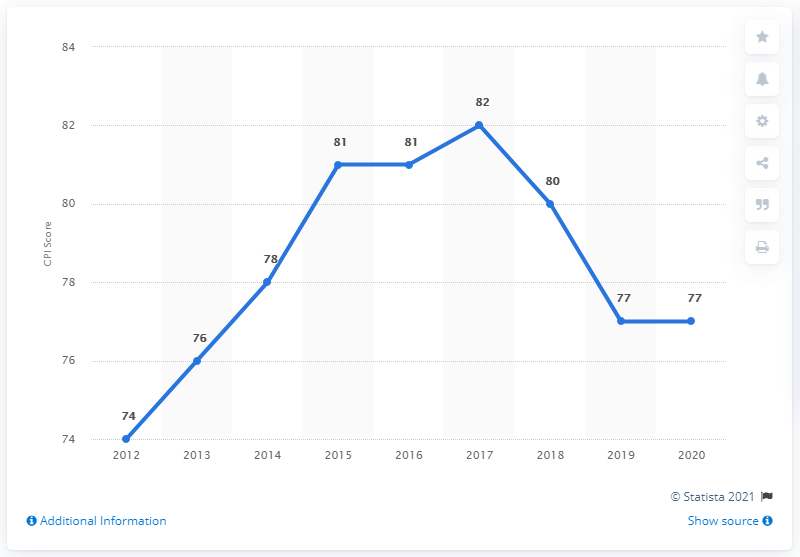Point out several critical features in this image. The Corruption Perception Index score in the United Kingdom in 2020 was 77. 